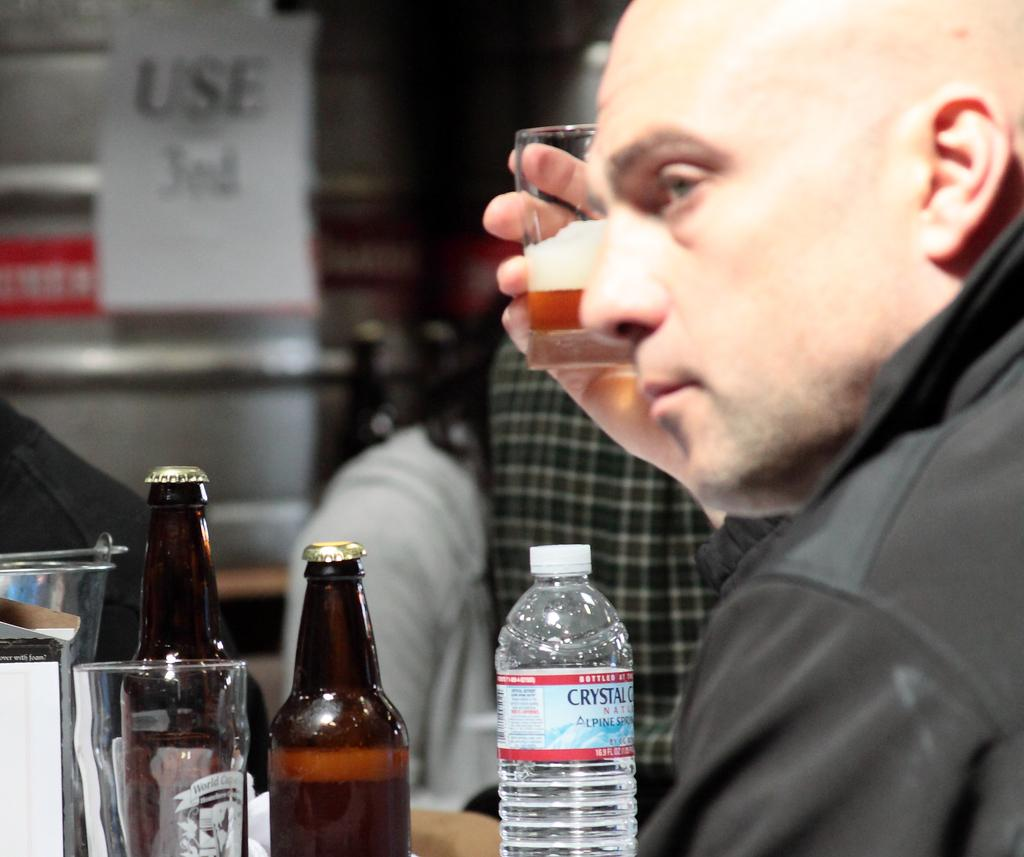<image>
Render a clear and concise summary of the photo. A man at a bar holding some booze in a glass with a bottle of Crystal water nearby. 